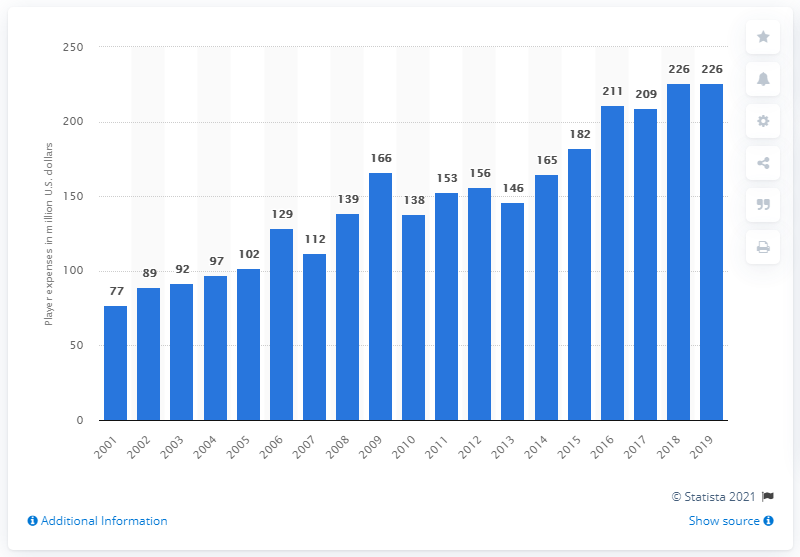Identify some key points in this picture. The player expenses of the New York Giants in the 2019 season were approximately 226. 